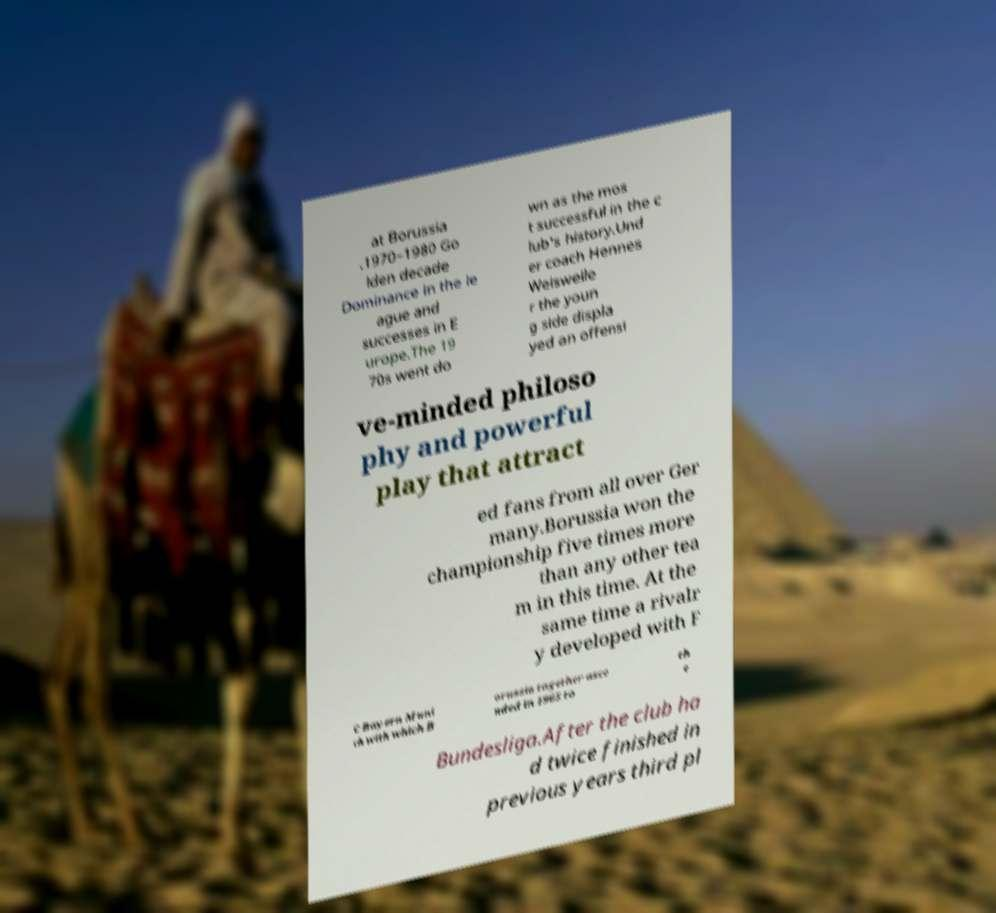Could you extract and type out the text from this image? at Borussia .1970–1980 Go lden decade Dominance in the le ague and successes in E urope.The 19 70s went do wn as the mos t successful in the c lub's history.Und er coach Hennes Weisweile r the youn g side displa yed an offensi ve-minded philoso phy and powerful play that attract ed fans from all over Ger many.Borussia won the championship five times more than any other tea m in this time. At the same time a rivalr y developed with F C Bayern Muni ch with which B orussia together asce nded in 1965 to th e Bundesliga.After the club ha d twice finished in previous years third pl 